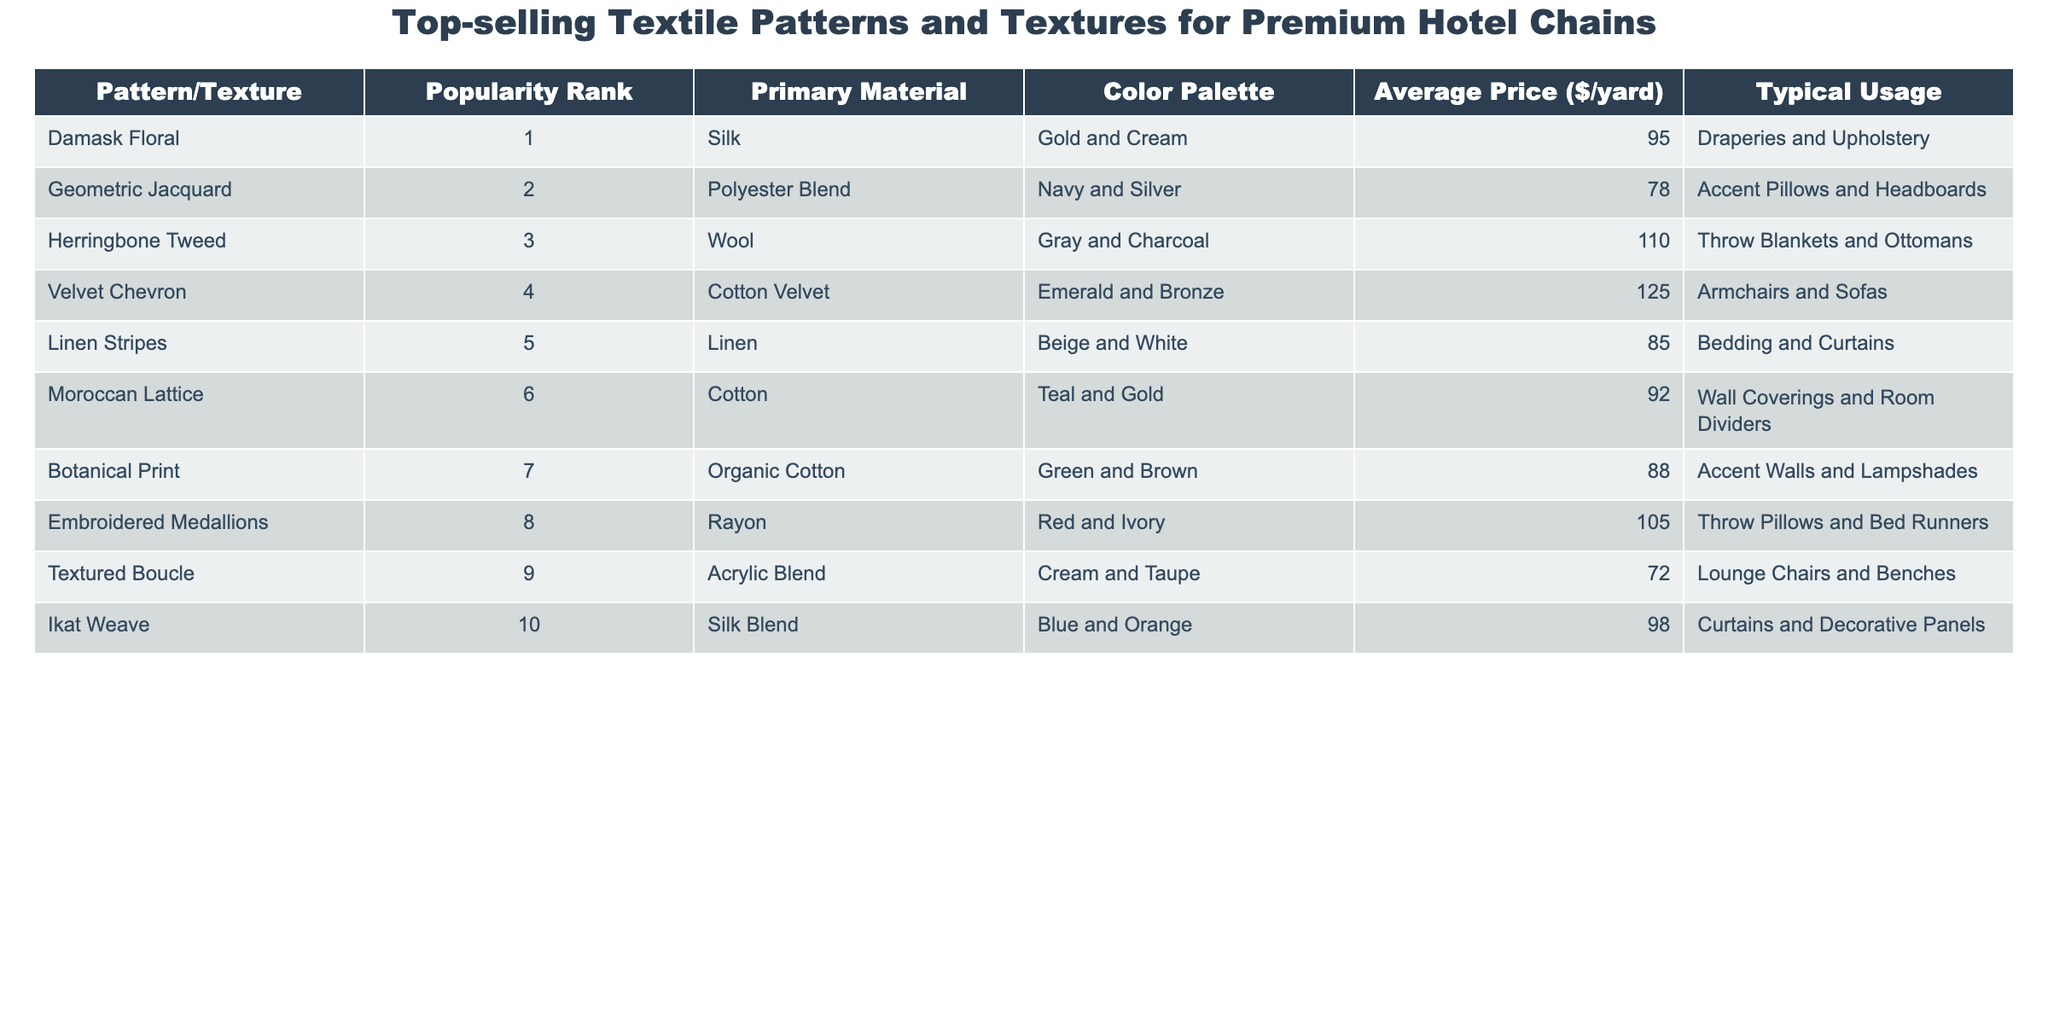What is the most popular textile pattern? The table indicates that the most popular textile pattern has a popularity rank of 1, which is the "Damask Floral."
Answer: Damask Floral Which textile pattern has the highest average price? By examining the average prices, I see that the "Velvet Chevron" has the highest price at $125 per yard.
Answer: Velvet Chevron What color palette is used in the "Geometric Jacquard"? The "Geometric Jacquard" is listed in the table with a color palette of Navy and Silver.
Answer: Navy and Silver How many patterns are made from silk? The table shows two patterns made from silk: "Damask Floral" and "Ikat Weave."
Answer: 2 What is the average price of patterns that utilize cotton? The average price for cotton patterns includes "Moroccan Lattice" ($92), "Botanical Print" ($88), and "Velvet Chevron" ($125), totaling $305. Dividing by 3 yields an average of $101.67.
Answer: Approximately $101.67 Is "Textured Boucle" more popular than "Ikat Weave"? The popularity rank of "Textured Boucle" is 9 and for "Ikat Weave," it is 10. Since a lower number indicates higher popularity, "Textured Boucle" is more popular than "Ikat Weave."
Answer: Yes What is the combined popularity rank of "Linen Stripes" and "Damask Floral"? The popularity ranks of "Linen Stripes" and "Damask Floral" are 5 and 1, respectively. Adding these ranks together results in a combined rank of 6.
Answer: 6 Which pattern is primarily used for throw pillows and bed runners? According to the table, "Embroidered Medallions" is specifically used for throw pillows and bed runners.
Answer: Embroidered Medallions What colors are associated with the "Herringbone Tweed"? The table explains that the "Herringbone Tweed" incorporates Gray and Charcoal as its color palette.
Answer: Gray and Charcoal Which textile has the lowest average price and what is it? The average price of "Textured Boucle" is the lowest at $72 per yard.
Answer: Textured Boucle 